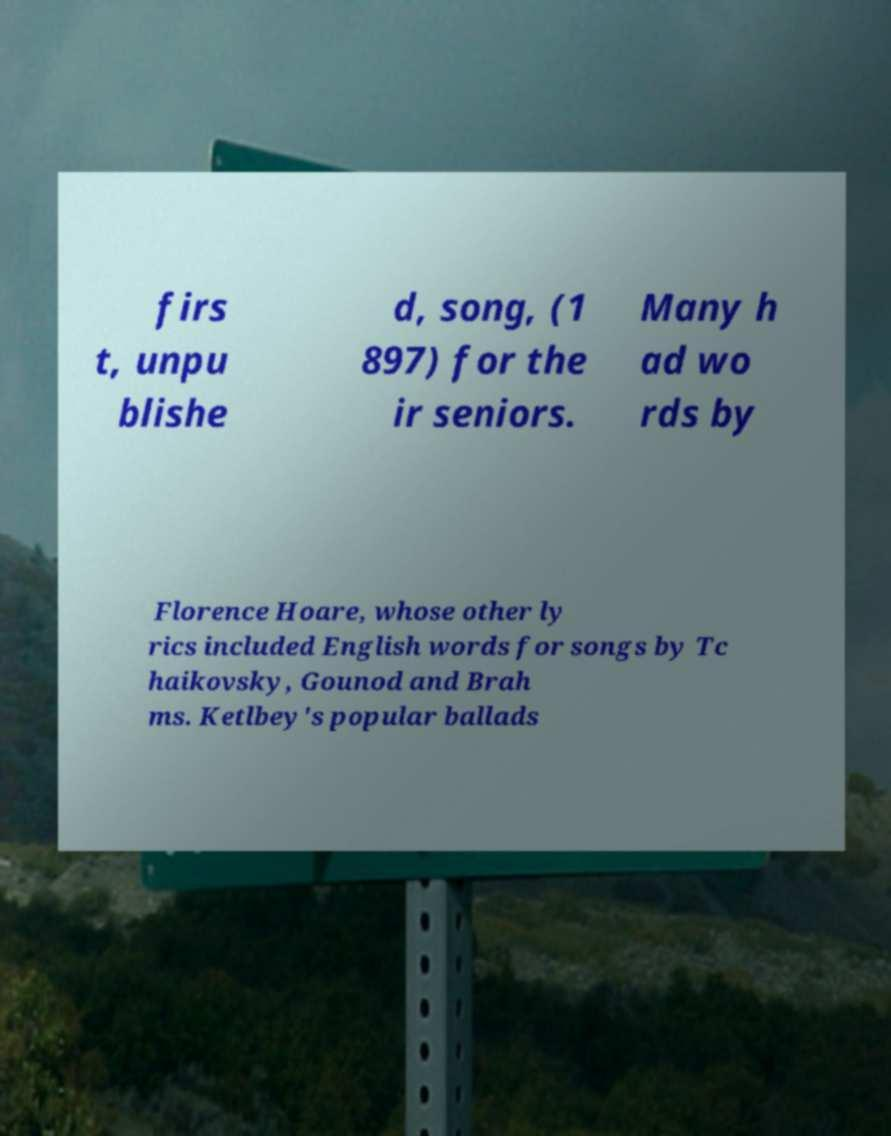Could you assist in decoding the text presented in this image and type it out clearly? firs t, unpu blishe d, song, (1 897) for the ir seniors. Many h ad wo rds by Florence Hoare, whose other ly rics included English words for songs by Tc haikovsky, Gounod and Brah ms. Ketlbey's popular ballads 